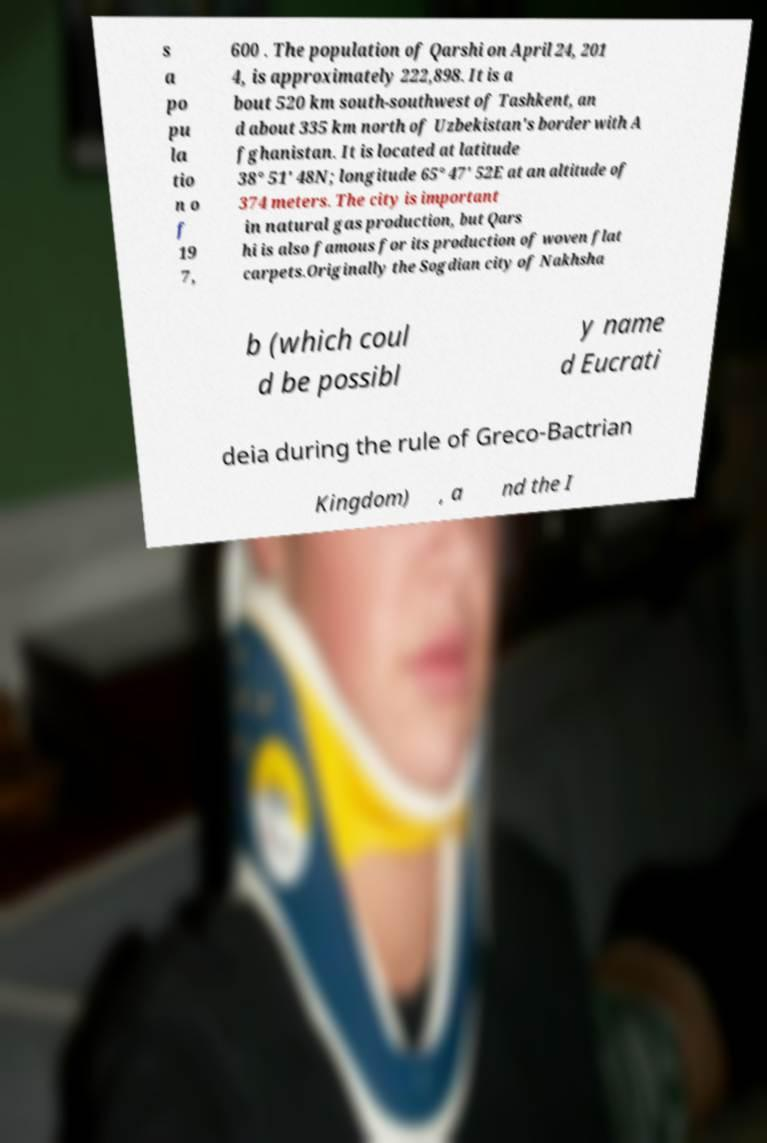There's text embedded in this image that I need extracted. Can you transcribe it verbatim? s a po pu la tio n o f 19 7, 600 . The population of Qarshi on April 24, 201 4, is approximately 222,898. It is a bout 520 km south-southwest of Tashkent, an d about 335 km north of Uzbekistan's border with A fghanistan. It is located at latitude 38° 51' 48N; longitude 65° 47' 52E at an altitude of 374 meters. The city is important in natural gas production, but Qars hi is also famous for its production of woven flat carpets.Originally the Sogdian city of Nakhsha b (which coul d be possibl y name d Eucrati deia during the rule of Greco-Bactrian Kingdom) , a nd the I 